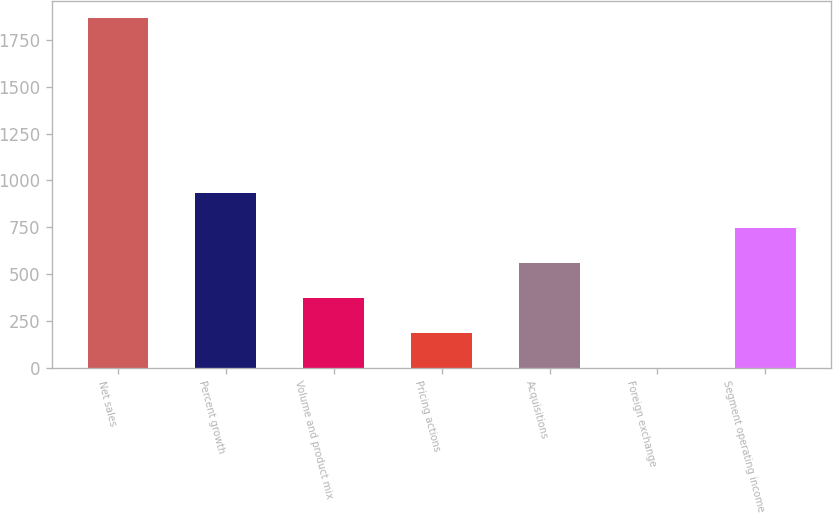Convert chart. <chart><loc_0><loc_0><loc_500><loc_500><bar_chart><fcel>Net sales<fcel>Percent growth<fcel>Volume and product mix<fcel>Pricing actions<fcel>Acquisitions<fcel>Foreign exchange<fcel>Segment operating income<nl><fcel>1864<fcel>932.8<fcel>374.08<fcel>187.84<fcel>560.32<fcel>1.6<fcel>746.56<nl></chart> 